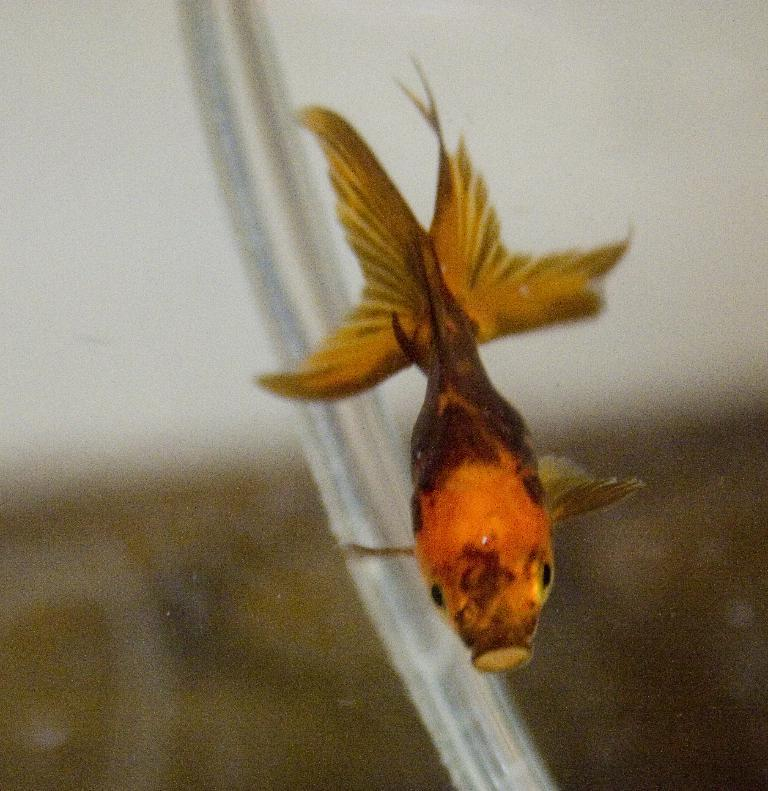What is the main subject of the image? There is a fish in the image. Where is the fish located? The fish is underwater. Can you describe the background of the image? The background of the image is blurred. What type of lock can be seen securing the hen in the image? There is no lock or hen present in the image; it features a fish underwater with a blurred background. 